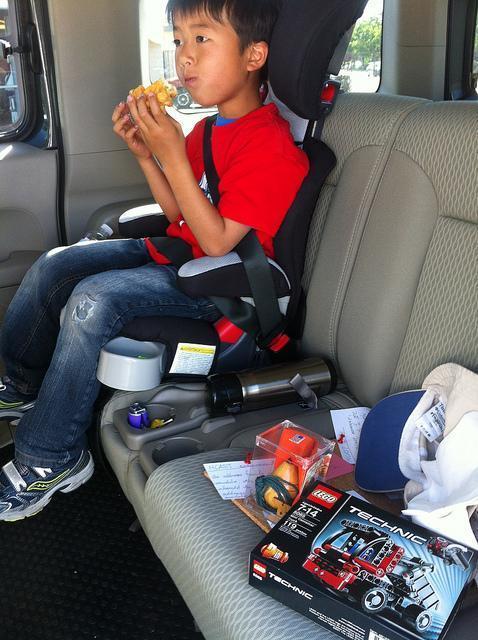How many elephants are there?
Give a very brief answer. 0. 